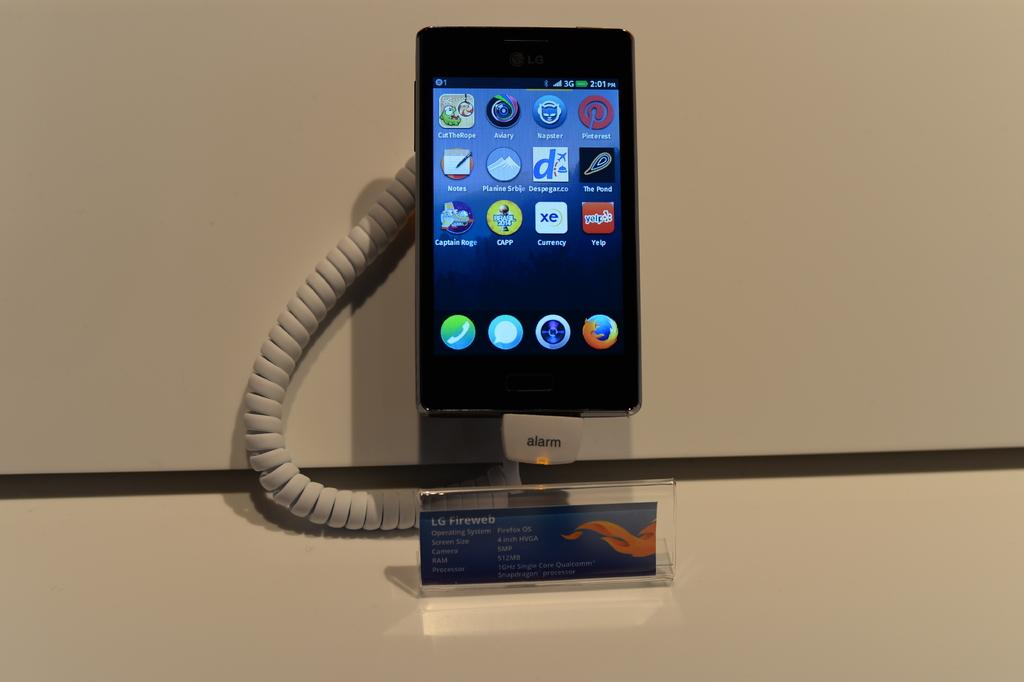<image>
Share a concise interpretation of the image provided. An LG Fireweb smartphone on display and attached to an antitheft device with a lit alarm. 